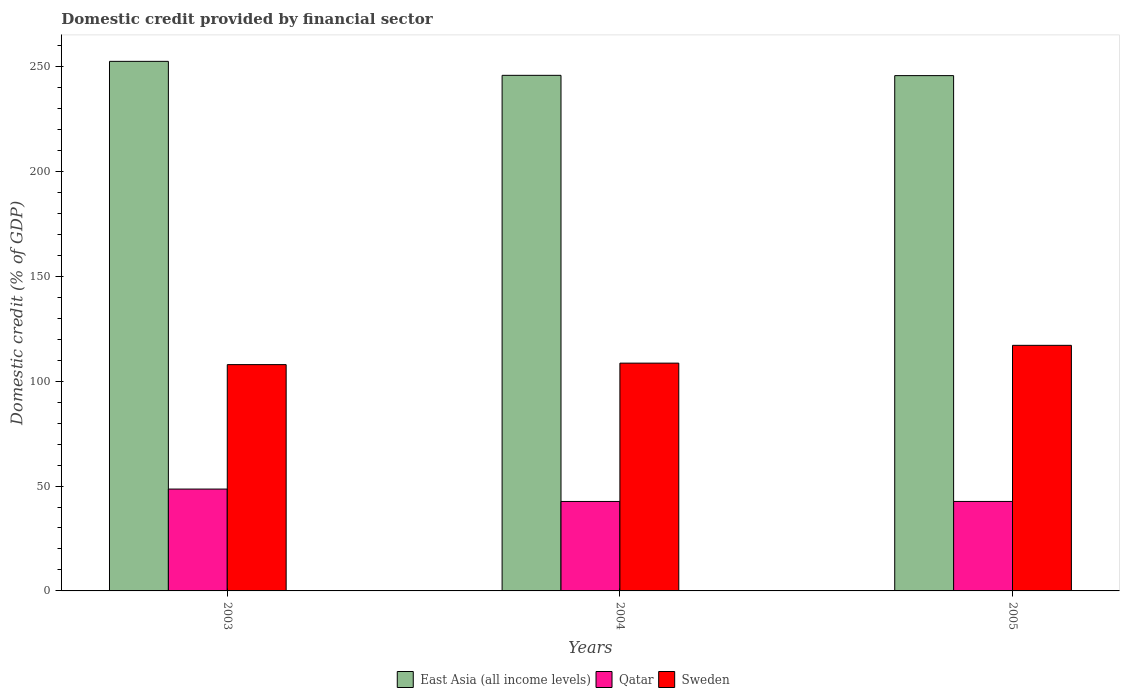Are the number of bars on each tick of the X-axis equal?
Your answer should be compact. Yes. How many bars are there on the 1st tick from the right?
Make the answer very short. 3. What is the domestic credit in East Asia (all income levels) in 2004?
Offer a terse response. 245.82. Across all years, what is the maximum domestic credit in Sweden?
Provide a succinct answer. 117.09. Across all years, what is the minimum domestic credit in Sweden?
Your answer should be very brief. 107.9. In which year was the domestic credit in Qatar maximum?
Keep it short and to the point. 2003. What is the total domestic credit in East Asia (all income levels) in the graph?
Provide a succinct answer. 744.01. What is the difference between the domestic credit in Qatar in 2003 and that in 2004?
Provide a short and direct response. 5.9. What is the difference between the domestic credit in Qatar in 2003 and the domestic credit in Sweden in 2004?
Your answer should be very brief. -60.05. What is the average domestic credit in Qatar per year?
Keep it short and to the point. 44.63. In the year 2004, what is the difference between the domestic credit in East Asia (all income levels) and domestic credit in Sweden?
Provide a short and direct response. 137.22. What is the ratio of the domestic credit in Qatar in 2003 to that in 2004?
Your answer should be compact. 1.14. Is the difference between the domestic credit in East Asia (all income levels) in 2004 and 2005 greater than the difference between the domestic credit in Sweden in 2004 and 2005?
Offer a very short reply. Yes. What is the difference between the highest and the second highest domestic credit in Qatar?
Make the answer very short. 5.89. What is the difference between the highest and the lowest domestic credit in Sweden?
Your answer should be very brief. 9.2. In how many years, is the domestic credit in Sweden greater than the average domestic credit in Sweden taken over all years?
Your answer should be very brief. 1. Is the sum of the domestic credit in Sweden in 2003 and 2005 greater than the maximum domestic credit in Qatar across all years?
Keep it short and to the point. Yes. Is it the case that in every year, the sum of the domestic credit in Sweden and domestic credit in East Asia (all income levels) is greater than the domestic credit in Qatar?
Keep it short and to the point. Yes. How many bars are there?
Give a very brief answer. 9. Are all the bars in the graph horizontal?
Keep it short and to the point. No. What is the difference between two consecutive major ticks on the Y-axis?
Your answer should be compact. 50. Are the values on the major ticks of Y-axis written in scientific E-notation?
Offer a terse response. No. Does the graph contain any zero values?
Offer a very short reply. No. What is the title of the graph?
Provide a succinct answer. Domestic credit provided by financial sector. Does "Curacao" appear as one of the legend labels in the graph?
Ensure brevity in your answer.  No. What is the label or title of the Y-axis?
Your answer should be compact. Domestic credit (% of GDP). What is the Domestic credit (% of GDP) of East Asia (all income levels) in 2003?
Provide a short and direct response. 252.49. What is the Domestic credit (% of GDP) of Qatar in 2003?
Keep it short and to the point. 48.56. What is the Domestic credit (% of GDP) in Sweden in 2003?
Ensure brevity in your answer.  107.9. What is the Domestic credit (% of GDP) of East Asia (all income levels) in 2004?
Make the answer very short. 245.82. What is the Domestic credit (% of GDP) of Qatar in 2004?
Ensure brevity in your answer.  42.65. What is the Domestic credit (% of GDP) of Sweden in 2004?
Your response must be concise. 108.61. What is the Domestic credit (% of GDP) in East Asia (all income levels) in 2005?
Your answer should be very brief. 245.69. What is the Domestic credit (% of GDP) of Qatar in 2005?
Offer a very short reply. 42.66. What is the Domestic credit (% of GDP) of Sweden in 2005?
Your answer should be very brief. 117.09. Across all years, what is the maximum Domestic credit (% of GDP) of East Asia (all income levels)?
Your response must be concise. 252.49. Across all years, what is the maximum Domestic credit (% of GDP) in Qatar?
Provide a succinct answer. 48.56. Across all years, what is the maximum Domestic credit (% of GDP) of Sweden?
Provide a succinct answer. 117.09. Across all years, what is the minimum Domestic credit (% of GDP) of East Asia (all income levels)?
Your response must be concise. 245.69. Across all years, what is the minimum Domestic credit (% of GDP) in Qatar?
Your answer should be compact. 42.65. Across all years, what is the minimum Domestic credit (% of GDP) of Sweden?
Keep it short and to the point. 107.9. What is the total Domestic credit (% of GDP) of East Asia (all income levels) in the graph?
Offer a very short reply. 744.01. What is the total Domestic credit (% of GDP) of Qatar in the graph?
Offer a terse response. 133.88. What is the total Domestic credit (% of GDP) of Sweden in the graph?
Give a very brief answer. 333.6. What is the difference between the Domestic credit (% of GDP) of East Asia (all income levels) in 2003 and that in 2004?
Your answer should be very brief. 6.67. What is the difference between the Domestic credit (% of GDP) of Qatar in 2003 and that in 2004?
Ensure brevity in your answer.  5.9. What is the difference between the Domestic credit (% of GDP) in Sweden in 2003 and that in 2004?
Ensure brevity in your answer.  -0.71. What is the difference between the Domestic credit (% of GDP) in East Asia (all income levels) in 2003 and that in 2005?
Your response must be concise. 6.8. What is the difference between the Domestic credit (% of GDP) in Qatar in 2003 and that in 2005?
Your answer should be compact. 5.89. What is the difference between the Domestic credit (% of GDP) of Sweden in 2003 and that in 2005?
Your answer should be very brief. -9.2. What is the difference between the Domestic credit (% of GDP) of East Asia (all income levels) in 2004 and that in 2005?
Your answer should be very brief. 0.13. What is the difference between the Domestic credit (% of GDP) of Qatar in 2004 and that in 2005?
Your response must be concise. -0.01. What is the difference between the Domestic credit (% of GDP) of Sweden in 2004 and that in 2005?
Your answer should be very brief. -8.49. What is the difference between the Domestic credit (% of GDP) of East Asia (all income levels) in 2003 and the Domestic credit (% of GDP) of Qatar in 2004?
Give a very brief answer. 209.84. What is the difference between the Domestic credit (% of GDP) in East Asia (all income levels) in 2003 and the Domestic credit (% of GDP) in Sweden in 2004?
Give a very brief answer. 143.88. What is the difference between the Domestic credit (% of GDP) in Qatar in 2003 and the Domestic credit (% of GDP) in Sweden in 2004?
Give a very brief answer. -60.05. What is the difference between the Domestic credit (% of GDP) of East Asia (all income levels) in 2003 and the Domestic credit (% of GDP) of Qatar in 2005?
Provide a succinct answer. 209.83. What is the difference between the Domestic credit (% of GDP) in East Asia (all income levels) in 2003 and the Domestic credit (% of GDP) in Sweden in 2005?
Offer a very short reply. 135.4. What is the difference between the Domestic credit (% of GDP) of Qatar in 2003 and the Domestic credit (% of GDP) of Sweden in 2005?
Give a very brief answer. -68.54. What is the difference between the Domestic credit (% of GDP) of East Asia (all income levels) in 2004 and the Domestic credit (% of GDP) of Qatar in 2005?
Your answer should be compact. 203.16. What is the difference between the Domestic credit (% of GDP) of East Asia (all income levels) in 2004 and the Domestic credit (% of GDP) of Sweden in 2005?
Your answer should be compact. 128.73. What is the difference between the Domestic credit (% of GDP) in Qatar in 2004 and the Domestic credit (% of GDP) in Sweden in 2005?
Offer a terse response. -74.44. What is the average Domestic credit (% of GDP) of East Asia (all income levels) per year?
Provide a short and direct response. 248. What is the average Domestic credit (% of GDP) in Qatar per year?
Ensure brevity in your answer.  44.63. What is the average Domestic credit (% of GDP) in Sweden per year?
Your answer should be very brief. 111.2. In the year 2003, what is the difference between the Domestic credit (% of GDP) of East Asia (all income levels) and Domestic credit (% of GDP) of Qatar?
Your answer should be compact. 203.93. In the year 2003, what is the difference between the Domestic credit (% of GDP) in East Asia (all income levels) and Domestic credit (% of GDP) in Sweden?
Your response must be concise. 144.59. In the year 2003, what is the difference between the Domestic credit (% of GDP) in Qatar and Domestic credit (% of GDP) in Sweden?
Give a very brief answer. -59.34. In the year 2004, what is the difference between the Domestic credit (% of GDP) in East Asia (all income levels) and Domestic credit (% of GDP) in Qatar?
Your answer should be compact. 203.17. In the year 2004, what is the difference between the Domestic credit (% of GDP) in East Asia (all income levels) and Domestic credit (% of GDP) in Sweden?
Make the answer very short. 137.22. In the year 2004, what is the difference between the Domestic credit (% of GDP) in Qatar and Domestic credit (% of GDP) in Sweden?
Your answer should be very brief. -65.95. In the year 2005, what is the difference between the Domestic credit (% of GDP) in East Asia (all income levels) and Domestic credit (% of GDP) in Qatar?
Make the answer very short. 203.03. In the year 2005, what is the difference between the Domestic credit (% of GDP) of East Asia (all income levels) and Domestic credit (% of GDP) of Sweden?
Offer a very short reply. 128.6. In the year 2005, what is the difference between the Domestic credit (% of GDP) in Qatar and Domestic credit (% of GDP) in Sweden?
Offer a very short reply. -74.43. What is the ratio of the Domestic credit (% of GDP) in East Asia (all income levels) in 2003 to that in 2004?
Your answer should be very brief. 1.03. What is the ratio of the Domestic credit (% of GDP) of Qatar in 2003 to that in 2004?
Ensure brevity in your answer.  1.14. What is the ratio of the Domestic credit (% of GDP) of Sweden in 2003 to that in 2004?
Your response must be concise. 0.99. What is the ratio of the Domestic credit (% of GDP) of East Asia (all income levels) in 2003 to that in 2005?
Your response must be concise. 1.03. What is the ratio of the Domestic credit (% of GDP) in Qatar in 2003 to that in 2005?
Ensure brevity in your answer.  1.14. What is the ratio of the Domestic credit (% of GDP) of Sweden in 2003 to that in 2005?
Your answer should be compact. 0.92. What is the ratio of the Domestic credit (% of GDP) in East Asia (all income levels) in 2004 to that in 2005?
Offer a very short reply. 1. What is the ratio of the Domestic credit (% of GDP) of Sweden in 2004 to that in 2005?
Offer a very short reply. 0.93. What is the difference between the highest and the second highest Domestic credit (% of GDP) of East Asia (all income levels)?
Give a very brief answer. 6.67. What is the difference between the highest and the second highest Domestic credit (% of GDP) in Qatar?
Your response must be concise. 5.89. What is the difference between the highest and the second highest Domestic credit (% of GDP) in Sweden?
Offer a very short reply. 8.49. What is the difference between the highest and the lowest Domestic credit (% of GDP) of East Asia (all income levels)?
Your answer should be very brief. 6.8. What is the difference between the highest and the lowest Domestic credit (% of GDP) in Qatar?
Keep it short and to the point. 5.9. What is the difference between the highest and the lowest Domestic credit (% of GDP) in Sweden?
Give a very brief answer. 9.2. 